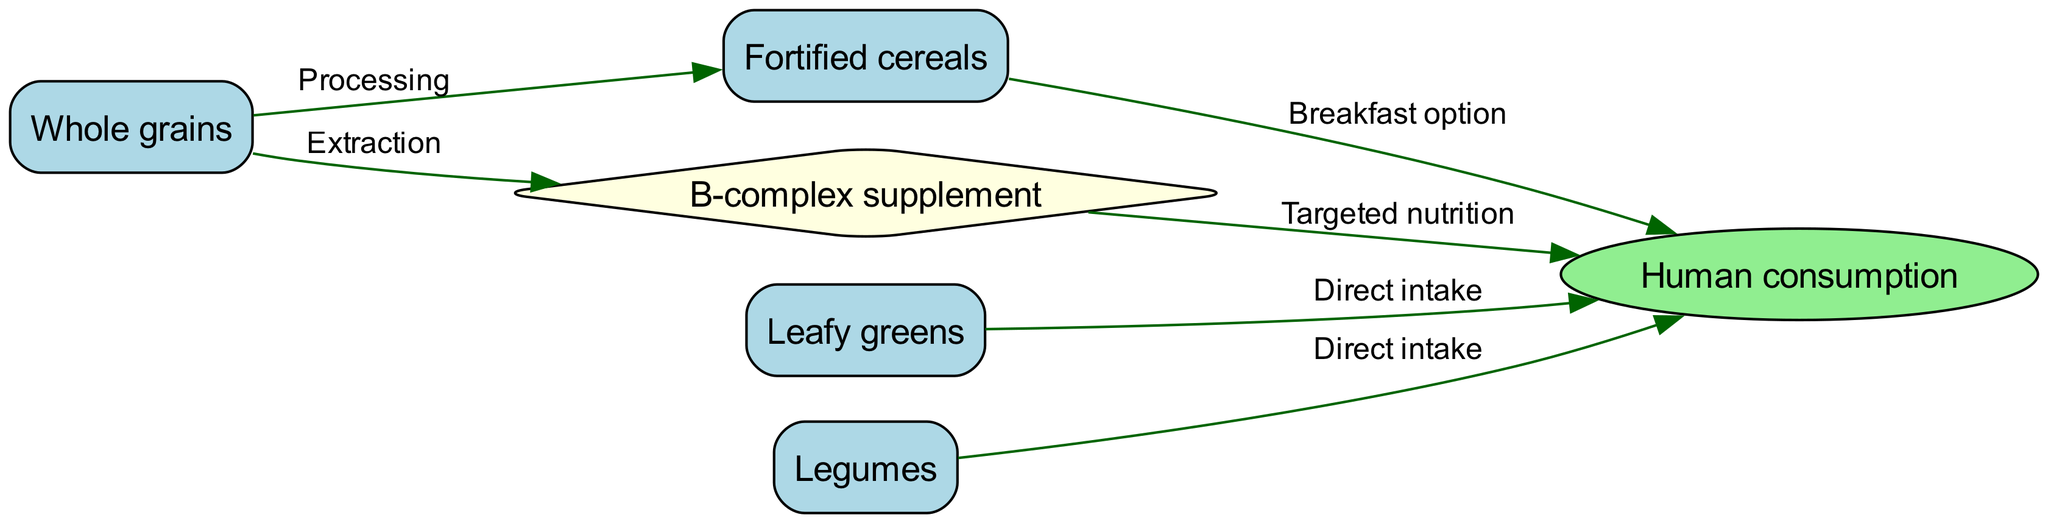What are the natural sources of B-complex vitamins shown in the diagram? The diagram includes natural sources such as Whole grains, Leafy greens, and Legumes as node representations. Those are listed directly as responses to the query about natural sources in the diagram.
Answer: Whole grains, Leafy greens, Legumes How many direct intake pathways are there to Human consumption? The edges from Leafy greens and Legumes to Human consumption indicate direct intake pathways. Counting these edges gives us the total number, which in this case is two.
Answer: 2 What is the first step in processing Whole grains according to the diagram? The diagram shows that the first step is 'Processing' as indicated by the edge leading from Whole grains to Fortified cereals. This processing step is essential to derive the next form.
Answer: Processing Which node represents the targeted nutrition approach for B-complex vitamins? The node labeled 'B-complex supplement' explicitly indicates the targeted nutrition approach as it is the unique diamond-shaped node connected to Human consumption. This node specifically denotes the supplementation aspect.
Answer: B-complex supplement What is the relationship between Fortified cereals and Human consumption? The edge from Fortified cereals to Human consumption is labeled as 'Breakfast option', which directly describes the relationship between these two nodes in the context of consumption.
Answer: Breakfast option What is the last step in the food chain for B-complex vitamins? The last step as depicted is represented by the arrow coming from B-complex supplement to Human consumption, indicating that the final consumption of these nutrients occurs in this step.
Answer: Human consumption Which node utilizes extraction in the food chain? The diagram shows that Whole grains connect to B-complex supplement through the 'Extraction' label, indicating that Whole grains are a source from which the supplement is derived.
Answer: Whole grains What is the total number of nodes in this food chain diagram? By counting every named entity within the nodes list in the diagram, we can determine the total number of nodes, which includes all nutritional items and the consumption methods. This results in six unique nodes overall.
Answer: 6 